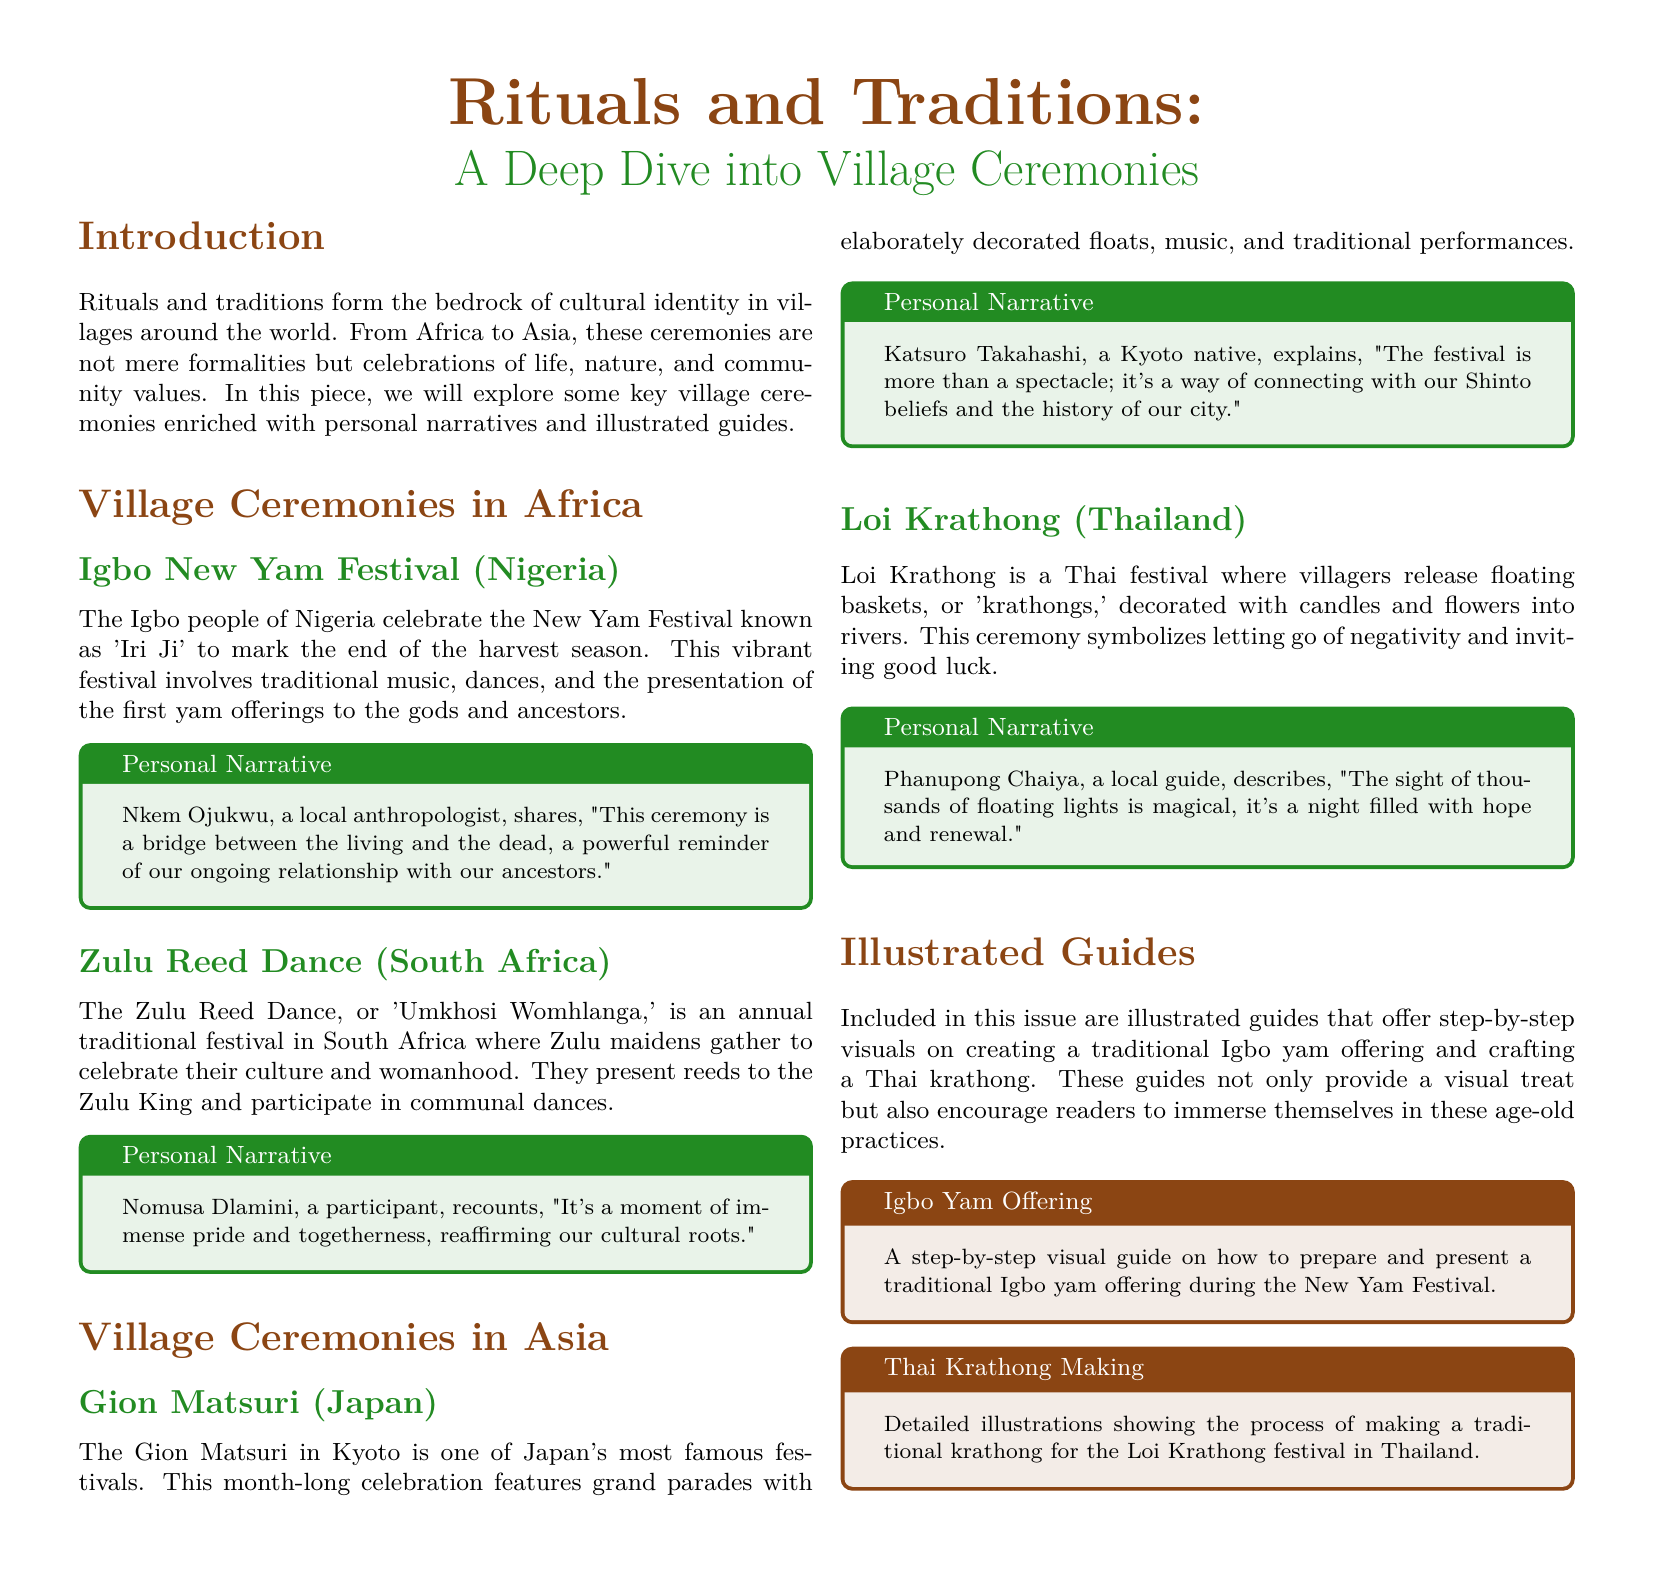What is the title of the document? The title is stated prominently at the top of the document as part of the header.
Answer: Rituals and Traditions: A Deep Dive into Village Ceremonies Who provides a personal narrative about the Igbo New Yam Festival? The personal narrative for the Igbo New Yam Festival includes the name of the person sharing their experience.
Answer: Nkem Ojukwu What festival is celebrated by the Zulu people? The document specifically names the festival celebrated by the Zulu people in South Africa.
Answer: Zulu Reed Dance How many village ceremonies are highlighted in the document? The document lists the total number of village ceremonies featured in both Africa and Asia sections.
Answer: Four What is the significance of the Gion Matsuri? The explanation of its significance includes a connection to cultural beliefs and history, as shared by a local.
Answer: Connection with Shinto beliefs What do villagers release during the Loi Krathong festival? The document describes a specific item that villagers release into the rivers during the festival.
Answer: Floating baskets 